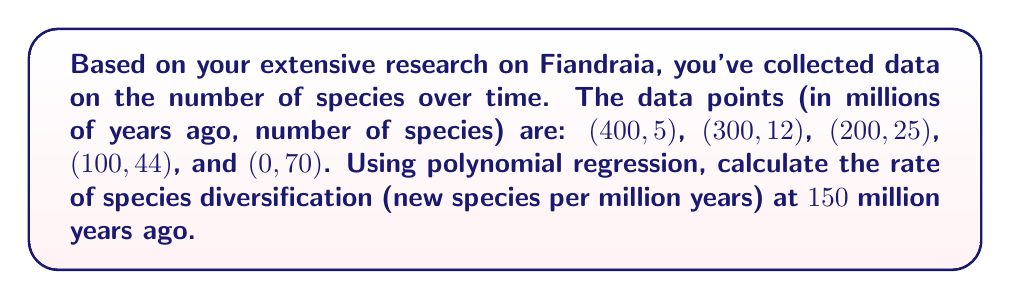Could you help me with this problem? To solve this problem, we'll follow these steps:

1) First, we need to fit a polynomial regression model to the data. Given the nature of species diversification, a quadratic model (2nd degree polynomial) should suffice:

   $$ y = ax^2 + bx + c $$

   where $y$ is the number of species and $x$ is time in millions of years ago.

2) We can use a computer algebra system to find the coefficients $a$, $b$, and $c$. The resulting equation is:

   $$ y = 0.00025x^2 - 0.245x + 70 $$

3) To find the rate of diversification, we need to find the derivative of this function:

   $$ \frac{dy}{dx} = 0.0005x - 0.245 $$

4) The rate of diversification at 150 million years ago is found by plugging $x = 150$ into this derivative:

   $$ \frac{dy}{dx}|_{x=150} = 0.0005(150) - 0.245 = 0.075 - 0.245 = -0.17 $$

5) The negative sign indicates that the number of species is increasing as we move forward in time (remember, larger $x$ values represent earlier times).

6) Therefore, the rate of species diversification at 150 million years ago is 0.17 new species per million years.
Answer: 0.17 new species per million years 